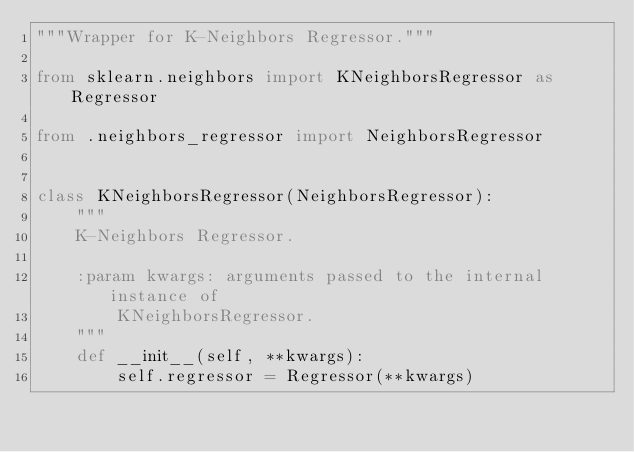Convert code to text. <code><loc_0><loc_0><loc_500><loc_500><_Python_>"""Wrapper for K-Neighbors Regressor."""

from sklearn.neighbors import KNeighborsRegressor as Regressor

from .neighbors_regressor import NeighborsRegressor


class KNeighborsRegressor(NeighborsRegressor):
    """
    K-Neighbors Regressor.

    :param kwargs: arguments passed to the internal instance of
        KNeighborsRegressor.
    """
    def __init__(self, **kwargs):
        self.regressor = Regressor(**kwargs)
</code> 